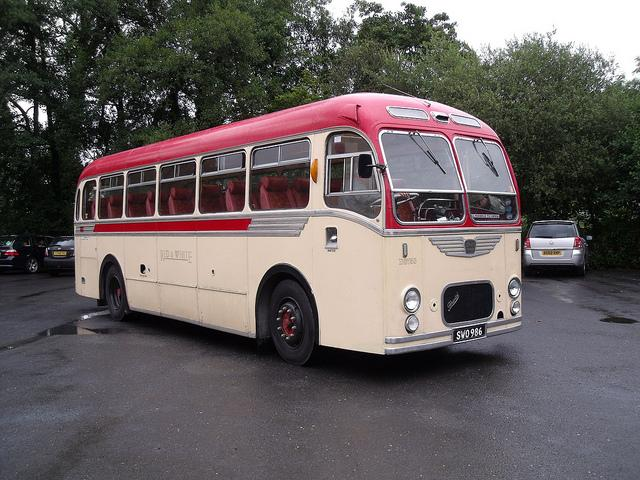What is the purpose of this vehicle? transportation 